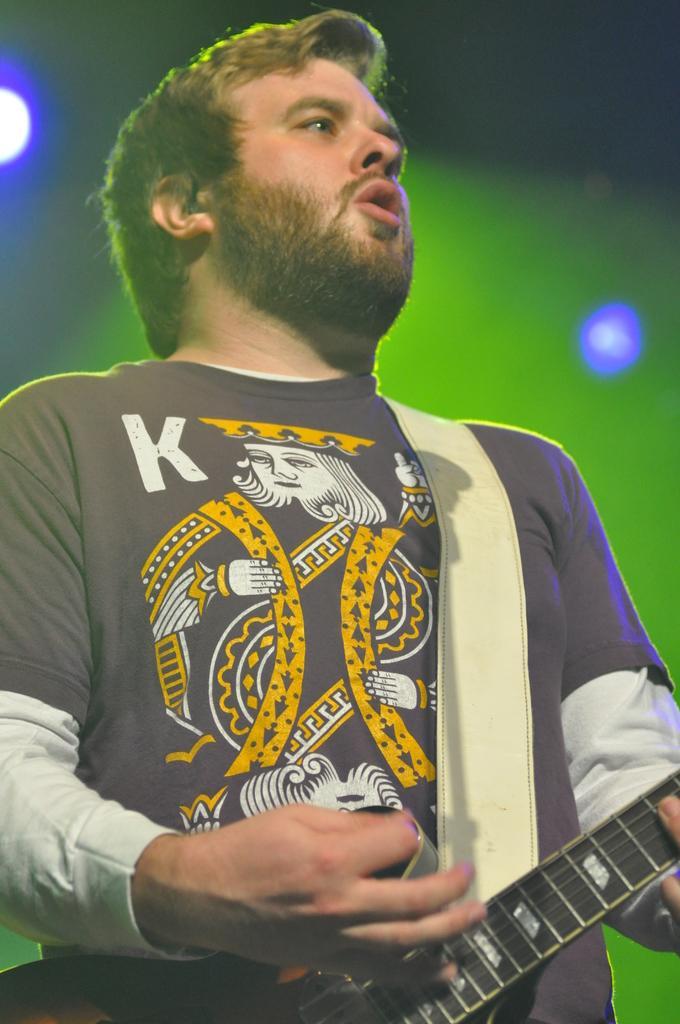Describe this image in one or two sentences. In this image there is a person wearing black color T-shirt holding guitar in his hands and at the background of the image there are lights. 